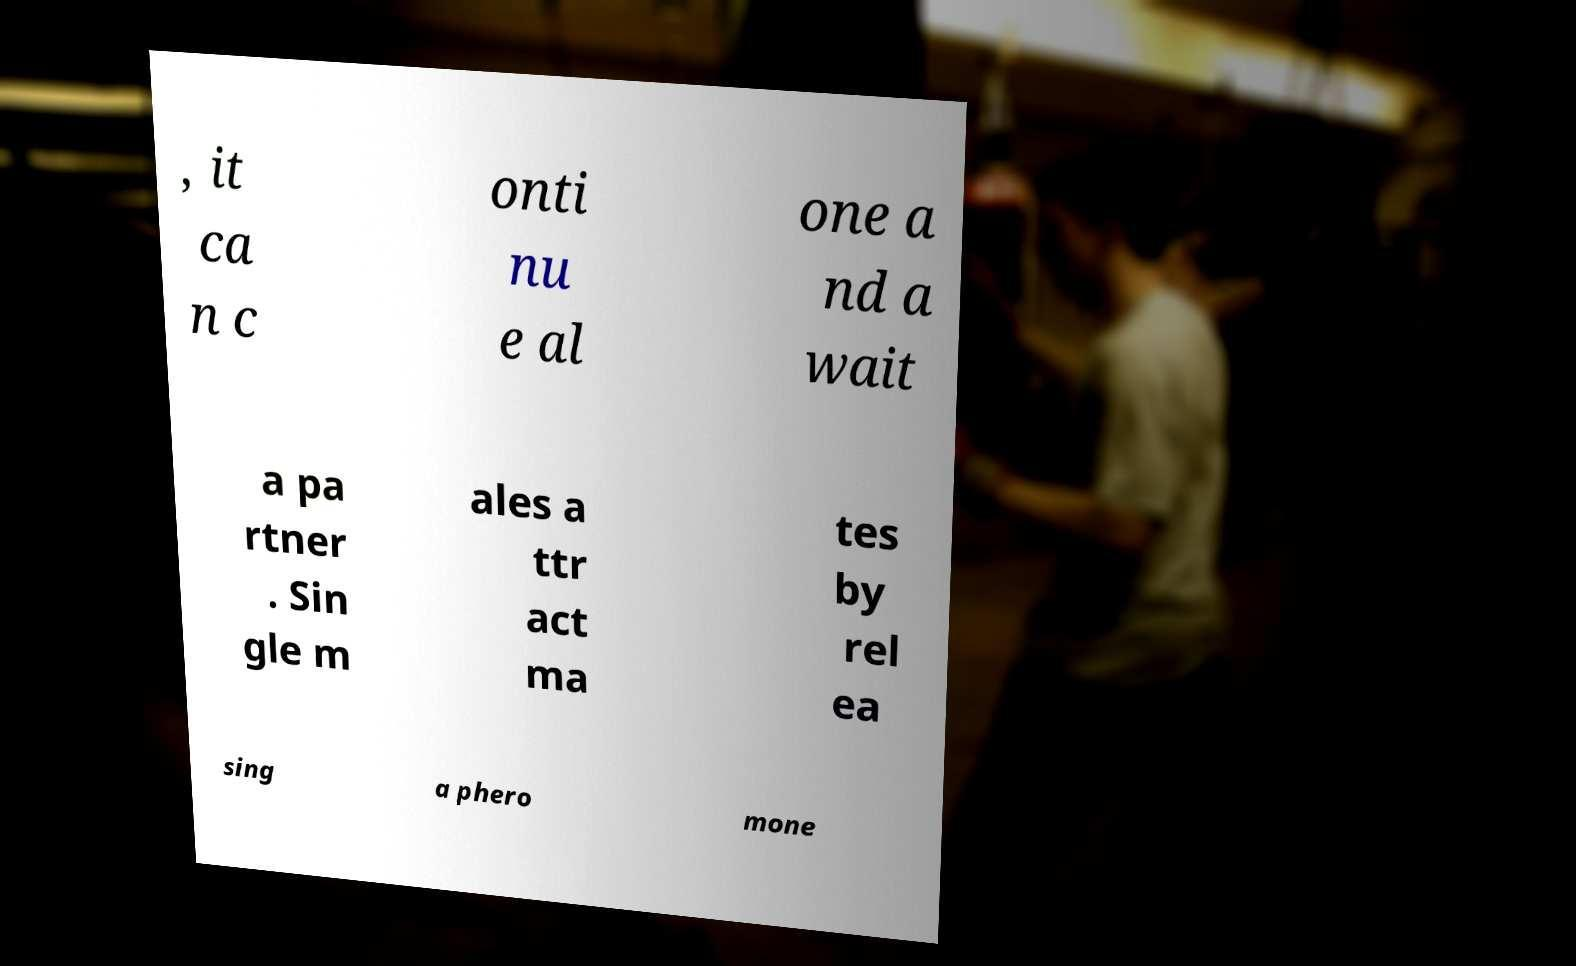Please identify and transcribe the text found in this image. , it ca n c onti nu e al one a nd a wait a pa rtner . Sin gle m ales a ttr act ma tes by rel ea sing a phero mone 